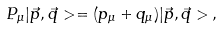Convert formula to latex. <formula><loc_0><loc_0><loc_500><loc_500>P _ { \mu } | \vec { p } , \vec { q } > = ( p _ { \mu } + q _ { \mu } ) | \vec { p } , \vec { q } > \, ,</formula> 